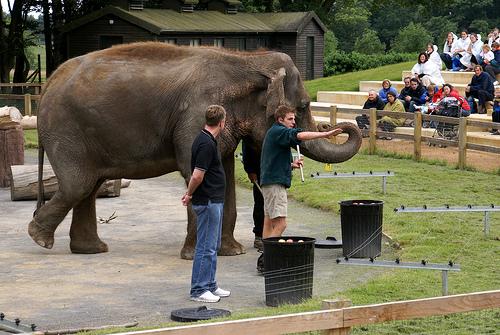How many people in ponchos?
Concise answer only. 5. Is this a giraffe?
Write a very short answer. No. Is the elephant large?
Answer briefly. Yes. 